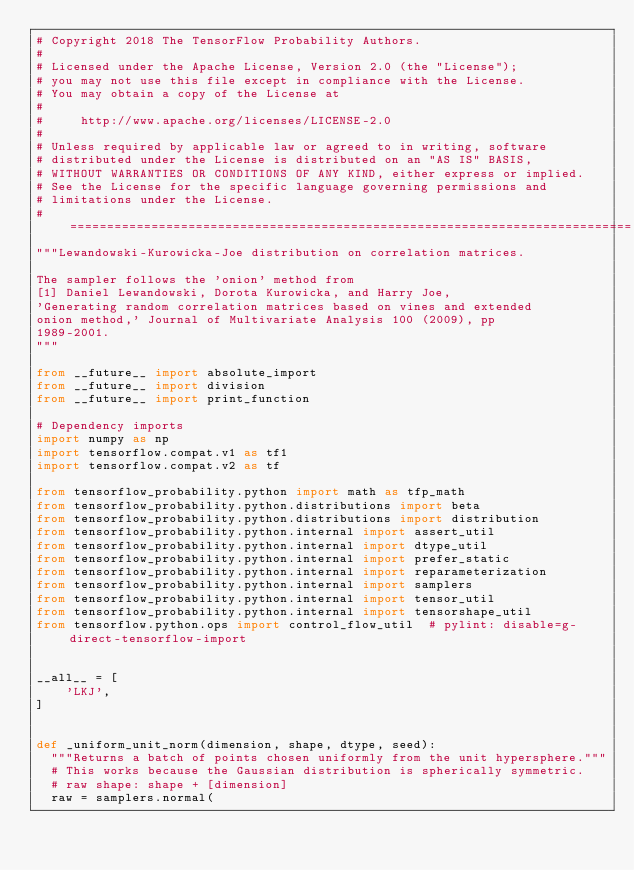Convert code to text. <code><loc_0><loc_0><loc_500><loc_500><_Python_># Copyright 2018 The TensorFlow Probability Authors.
#
# Licensed under the Apache License, Version 2.0 (the "License");
# you may not use this file except in compliance with the License.
# You may obtain a copy of the License at
#
#     http://www.apache.org/licenses/LICENSE-2.0
#
# Unless required by applicable law or agreed to in writing, software
# distributed under the License is distributed on an "AS IS" BASIS,
# WITHOUT WARRANTIES OR CONDITIONS OF ANY KIND, either express or implied.
# See the License for the specific language governing permissions and
# limitations under the License.
# ============================================================================
"""Lewandowski-Kurowicka-Joe distribution on correlation matrices.

The sampler follows the 'onion' method from
[1] Daniel Lewandowski, Dorota Kurowicka, and Harry Joe,
'Generating random correlation matrices based on vines and extended
onion method,' Journal of Multivariate Analysis 100 (2009), pp
1989-2001.
"""

from __future__ import absolute_import
from __future__ import division
from __future__ import print_function

# Dependency imports
import numpy as np
import tensorflow.compat.v1 as tf1
import tensorflow.compat.v2 as tf

from tensorflow_probability.python import math as tfp_math
from tensorflow_probability.python.distributions import beta
from tensorflow_probability.python.distributions import distribution
from tensorflow_probability.python.internal import assert_util
from tensorflow_probability.python.internal import dtype_util
from tensorflow_probability.python.internal import prefer_static
from tensorflow_probability.python.internal import reparameterization
from tensorflow_probability.python.internal import samplers
from tensorflow_probability.python.internal import tensor_util
from tensorflow_probability.python.internal import tensorshape_util
from tensorflow.python.ops import control_flow_util  # pylint: disable=g-direct-tensorflow-import


__all__ = [
    'LKJ',
]


def _uniform_unit_norm(dimension, shape, dtype, seed):
  """Returns a batch of points chosen uniformly from the unit hypersphere."""
  # This works because the Gaussian distribution is spherically symmetric.
  # raw shape: shape + [dimension]
  raw = samplers.normal(</code> 